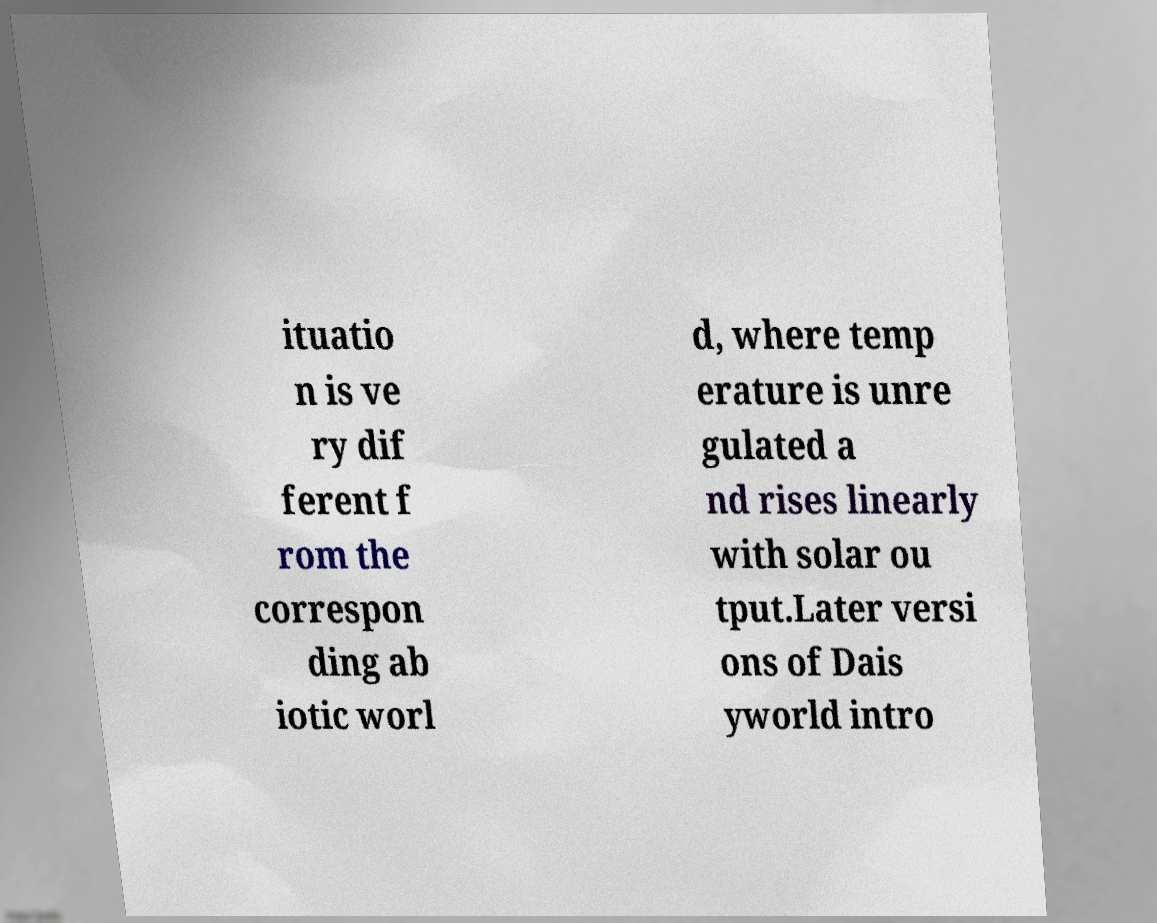There's text embedded in this image that I need extracted. Can you transcribe it verbatim? ituatio n is ve ry dif ferent f rom the correspon ding ab iotic worl d, where temp erature is unre gulated a nd rises linearly with solar ou tput.Later versi ons of Dais yworld intro 